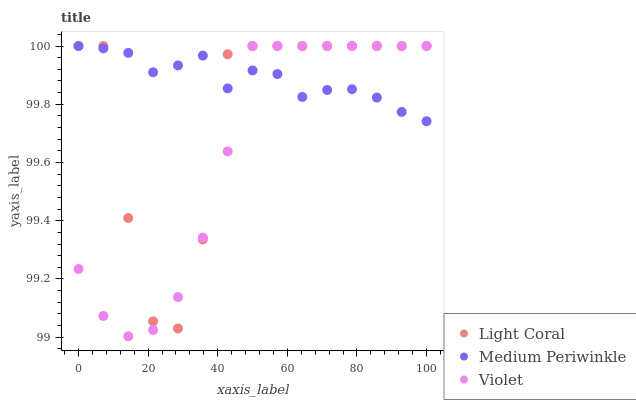Does Violet have the minimum area under the curve?
Answer yes or no. Yes. Does Medium Periwinkle have the maximum area under the curve?
Answer yes or no. Yes. Does Medium Periwinkle have the minimum area under the curve?
Answer yes or no. No. Does Violet have the maximum area under the curve?
Answer yes or no. No. Is Medium Periwinkle the smoothest?
Answer yes or no. Yes. Is Light Coral the roughest?
Answer yes or no. Yes. Is Violet the smoothest?
Answer yes or no. No. Is Violet the roughest?
Answer yes or no. No. Does Violet have the lowest value?
Answer yes or no. Yes. Does Medium Periwinkle have the lowest value?
Answer yes or no. No. Does Violet have the highest value?
Answer yes or no. Yes. Does Light Coral intersect Medium Periwinkle?
Answer yes or no. Yes. Is Light Coral less than Medium Periwinkle?
Answer yes or no. No. Is Light Coral greater than Medium Periwinkle?
Answer yes or no. No. 